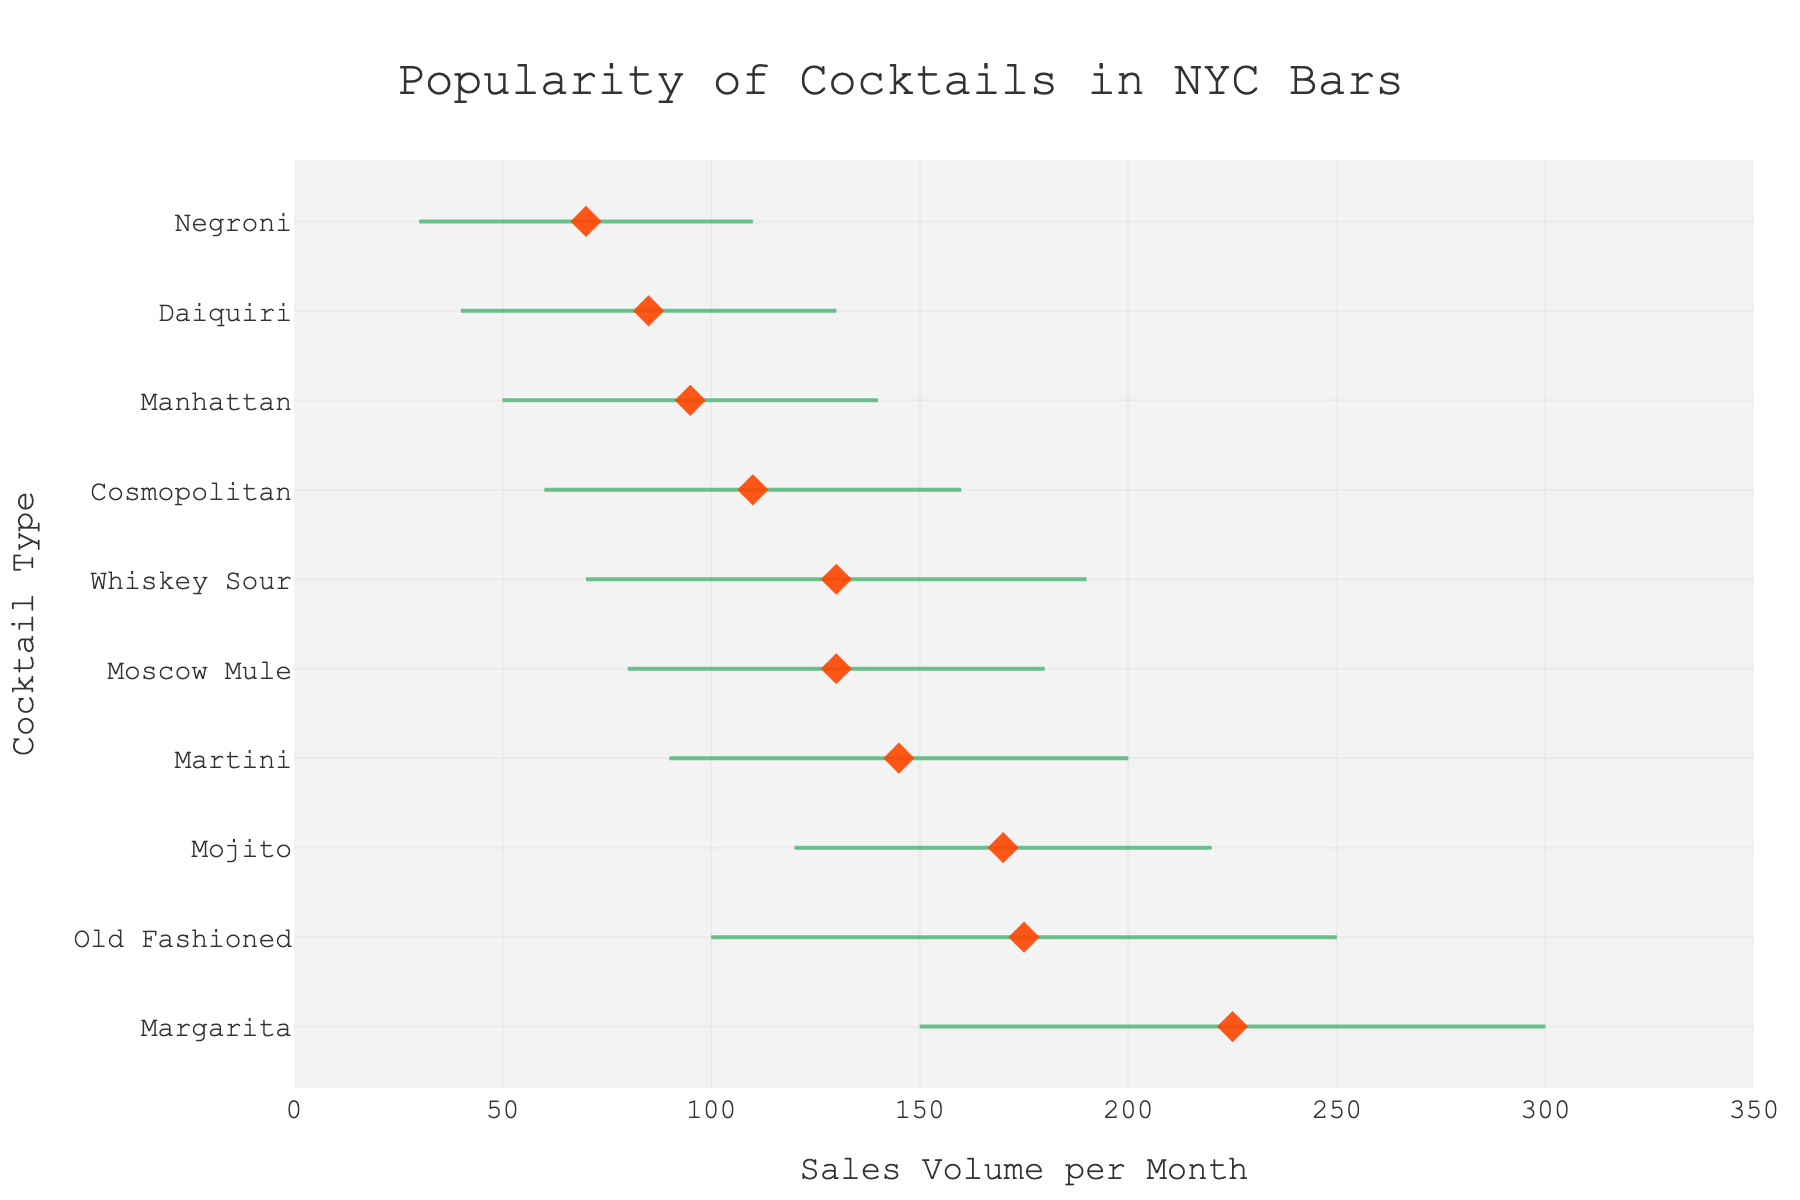what is the title of the plot? The title of the plot is usually displayed at the top center of the figure. In this case, it reads "Popularity of Cocktails in NYC Bars."
Answer: Popularity of Cocktails in NYC Bars What is the average sales volume for Margaritas? By looking at the dot for the Margarita category, which is marked with an orange diamond on the horizontal axis, we see that the average sales volume is approximately 225 units per month.
Answer: 225 Which cocktail has the highest maximum sales volume? The maximum sales volume for each cocktail is indicated by the endpoint of the horizontal lines. The Margarita, with its line extending furthest to the right, has the highest maximum sales volume of 300 units per month.
Answer: Margarita How does the average sales volume of Martinis compare to that of Cosmopolitans? The average sales volumes are indicated by the orange diamond markers. For Martinis, the diamond is at 145, and for Cosmopolitans, it is at 110. By comparing these markers, we see that Martinis have a higher average sales volume than Cosmopolitans.
Answer: Martinis have a higher average sales volume What is the sales volume range for Whiskey Sours? The sales volume range for each cocktail is the difference between the minimum and maximum sales volumes. For Whiskey Sours, the range is from 70 to 190 units per month. Thus, the range is 190 - 70 = 120 units per month.
Answer: 120 Among Mojitos, Margaritas, and Old Fashioneds, which has the smallest minimum sales volume? The minimum sales volumes are where the horizontal lines begin. For Mojitos, it's 120; for Margaritas, it's 150; and for Old Fashioneds, it's 100. Old Fashioneds have the smallest minimum sales volume.
Answer: Old Fashioneds How many different cocktail types are there in the plot? Each row corresponds to a different cocktail type, and by counting the rows, we can determine there are 10 different cocktail types shown in the plot.
Answer: 10 What's the difference between the maximum sales volumes of Negronis and Daiquiris? The maximum sales volume for Negronis is 110, and for Daiquiris, it's 130. The difference between these values is 130 - 110 = 20 units per month.
Answer: 20 What is the color of the markers indicating the average sales volumes? The markers indicating the average sales volumes are in the shape of a diamond and are colored in an orange hue.
Answer: Orange Which cocktail has the smallest average sales volume? The smallest average sales volume will be indicated by the leftmost orange diamond marker. By examining the plot, the diamond for Negronis is positioned furthest to the left at 70 units per month.
Answer: Negronis 